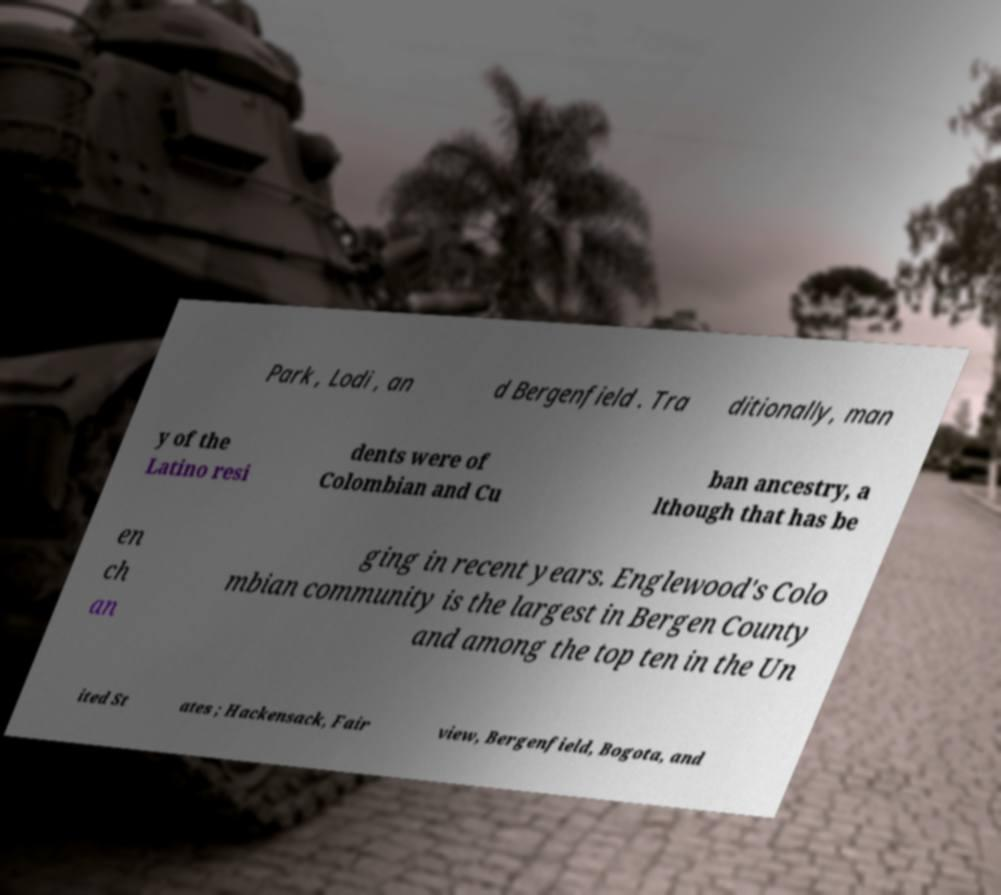For documentation purposes, I need the text within this image transcribed. Could you provide that? Park , Lodi , an d Bergenfield . Tra ditionally, man y of the Latino resi dents were of Colombian and Cu ban ancestry, a lthough that has be en ch an ging in recent years. Englewood's Colo mbian community is the largest in Bergen County and among the top ten in the Un ited St ates ; Hackensack, Fair view, Bergenfield, Bogota, and 